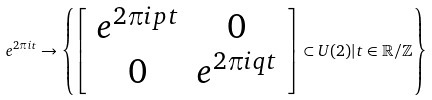Convert formula to latex. <formula><loc_0><loc_0><loc_500><loc_500>e ^ { 2 \pi { i } t } \rightarrow \left \{ \left [ \begin{array} { c c } e ^ { 2 \pi { i } p t } & 0 \\ 0 & e ^ { 2 \pi { i } q t } \end{array} \right ] \subset { U } ( 2 ) | { t } \in \mathbb { R } / \mathbb { Z } \right \}</formula> 